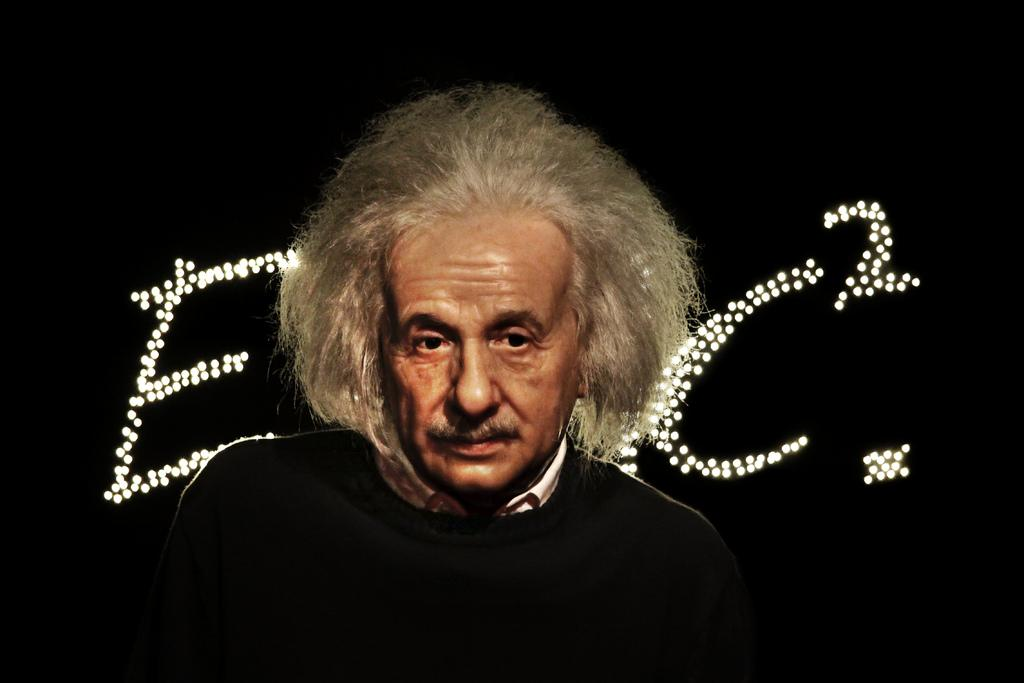Who is present in the image? There is a man in the image. What is the man wearing? The man is wearing a sweater. What type of squirrel can be seen running in the image? There is no squirrel present in the image, and therefore no such activity can be observed. 